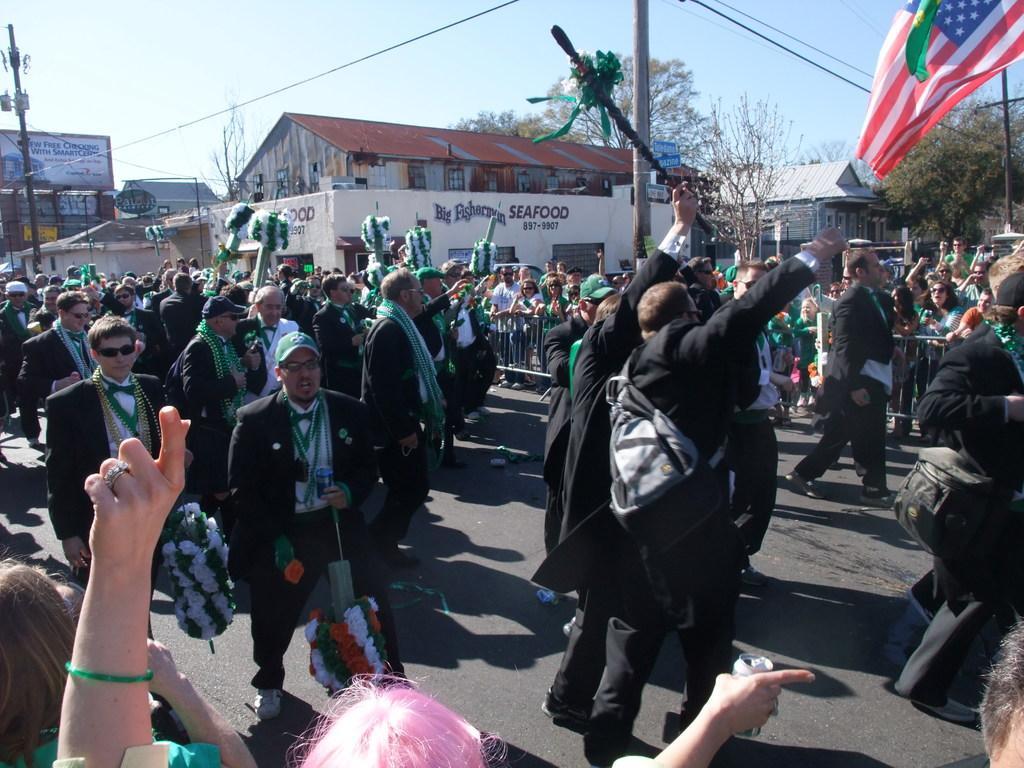In one or two sentences, can you explain what this image depicts? In this picture I can see many peoples who are wearing black suit and holding the sticks. Beside them I can see the group of persons who are standing near to the fencing. In the background I can see the trees, poles, electric wires, shed, building and other objects. At the top I can see the sky. 